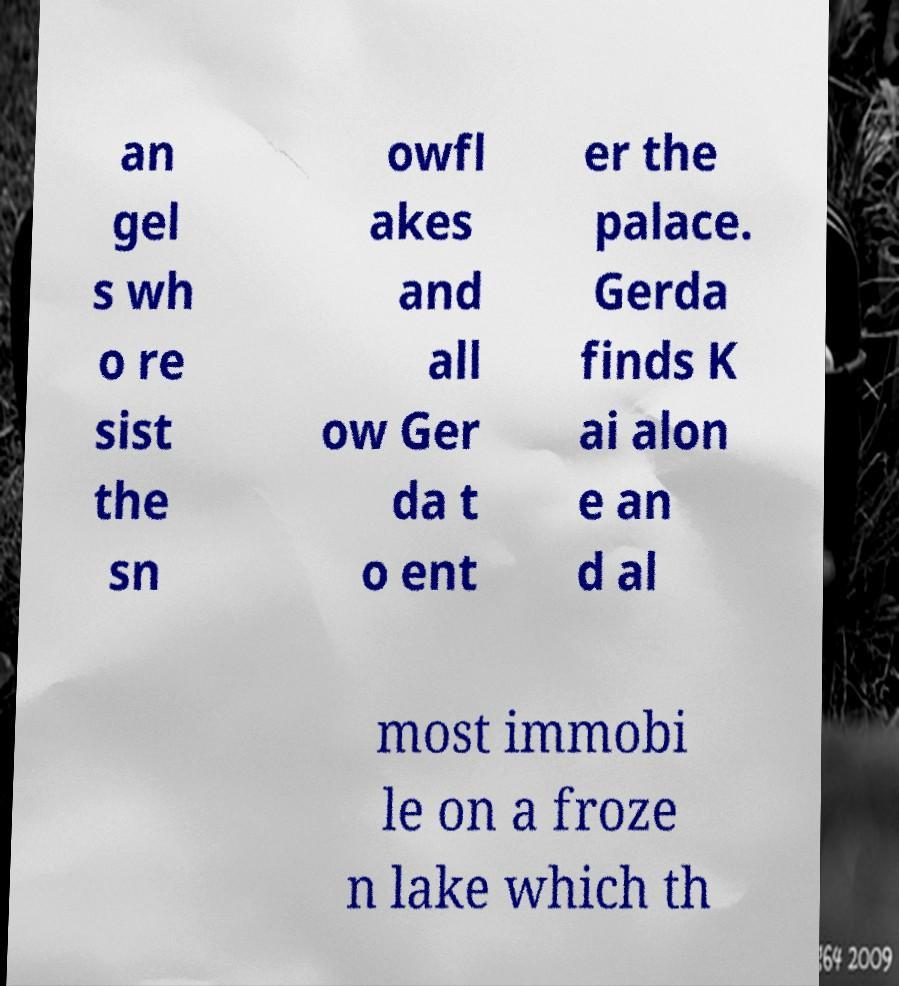There's text embedded in this image that I need extracted. Can you transcribe it verbatim? an gel s wh o re sist the sn owfl akes and all ow Ger da t o ent er the palace. Gerda finds K ai alon e an d al most immobi le on a froze n lake which th 